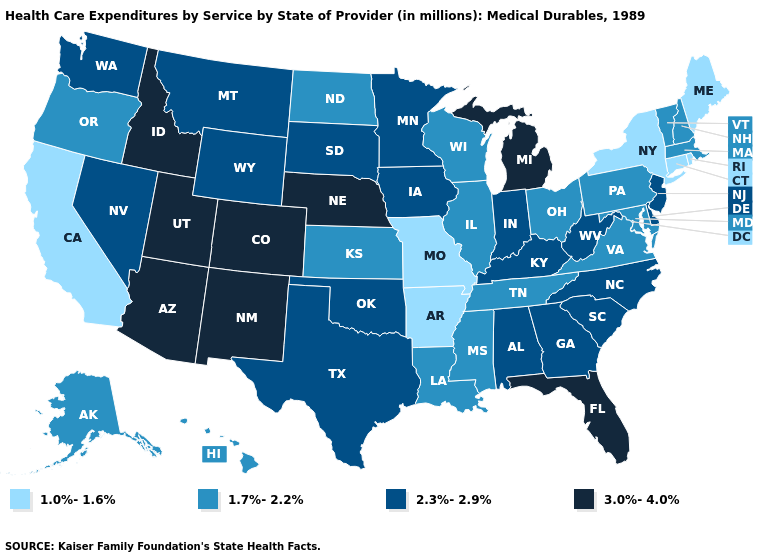Name the states that have a value in the range 1.7%-2.2%?
Be succinct. Alaska, Hawaii, Illinois, Kansas, Louisiana, Maryland, Massachusetts, Mississippi, New Hampshire, North Dakota, Ohio, Oregon, Pennsylvania, Tennessee, Vermont, Virginia, Wisconsin. Does Oklahoma have a higher value than Massachusetts?
Short answer required. Yes. Which states have the lowest value in the USA?
Answer briefly. Arkansas, California, Connecticut, Maine, Missouri, New York, Rhode Island. Name the states that have a value in the range 1.7%-2.2%?
Quick response, please. Alaska, Hawaii, Illinois, Kansas, Louisiana, Maryland, Massachusetts, Mississippi, New Hampshire, North Dakota, Ohio, Oregon, Pennsylvania, Tennessee, Vermont, Virginia, Wisconsin. What is the value of North Carolina?
Be succinct. 2.3%-2.9%. Which states have the lowest value in the South?
Answer briefly. Arkansas. Name the states that have a value in the range 3.0%-4.0%?
Write a very short answer. Arizona, Colorado, Florida, Idaho, Michigan, Nebraska, New Mexico, Utah. Does Nevada have the highest value in the USA?
Answer briefly. No. What is the lowest value in states that border Nevada?
Quick response, please. 1.0%-1.6%. Which states have the highest value in the USA?
Answer briefly. Arizona, Colorado, Florida, Idaho, Michigan, Nebraska, New Mexico, Utah. Does Iowa have the highest value in the MidWest?
Keep it brief. No. Is the legend a continuous bar?
Keep it brief. No. Name the states that have a value in the range 1.7%-2.2%?
Give a very brief answer. Alaska, Hawaii, Illinois, Kansas, Louisiana, Maryland, Massachusetts, Mississippi, New Hampshire, North Dakota, Ohio, Oregon, Pennsylvania, Tennessee, Vermont, Virginia, Wisconsin. What is the value of Washington?
Write a very short answer. 2.3%-2.9%. What is the highest value in states that border Ohio?
Short answer required. 3.0%-4.0%. 